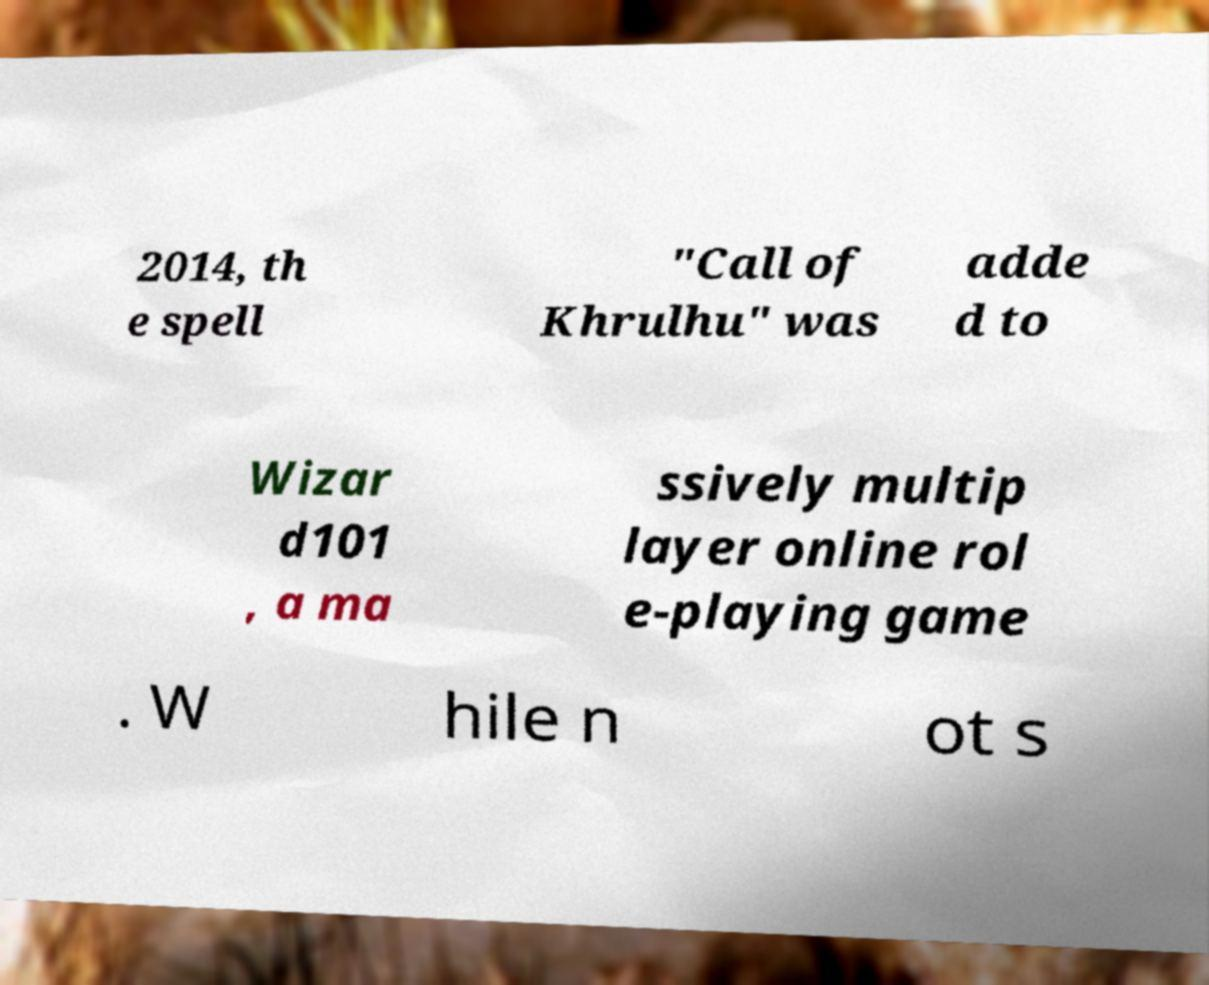Could you extract and type out the text from this image? 2014, th e spell "Call of Khrulhu" was adde d to Wizar d101 , a ma ssively multip layer online rol e-playing game . W hile n ot s 